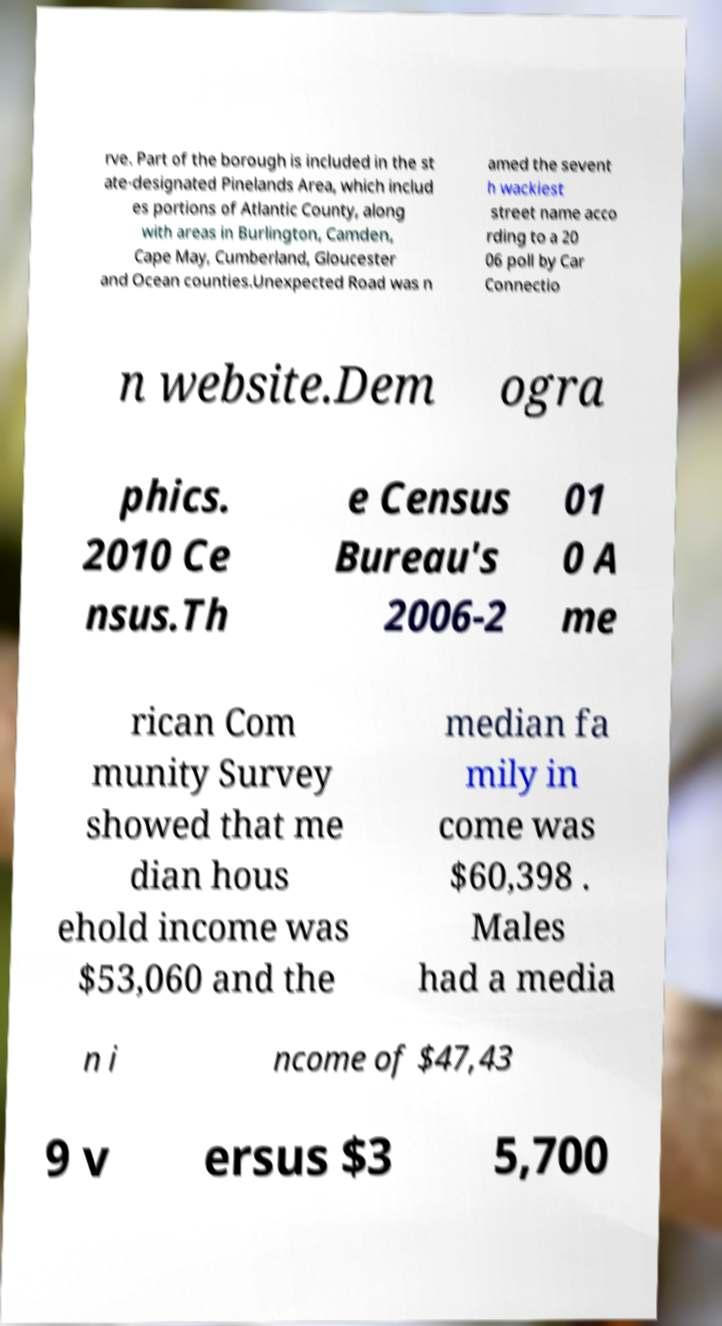Can you accurately transcribe the text from the provided image for me? rve. Part of the borough is included in the st ate-designated Pinelands Area, which includ es portions of Atlantic County, along with areas in Burlington, Camden, Cape May, Cumberland, Gloucester and Ocean counties.Unexpected Road was n amed the sevent h wackiest street name acco rding to a 20 06 poll by Car Connectio n website.Dem ogra phics. 2010 Ce nsus.Th e Census Bureau's 2006-2 01 0 A me rican Com munity Survey showed that me dian hous ehold income was $53,060 and the median fa mily in come was $60,398 . Males had a media n i ncome of $47,43 9 v ersus $3 5,700 